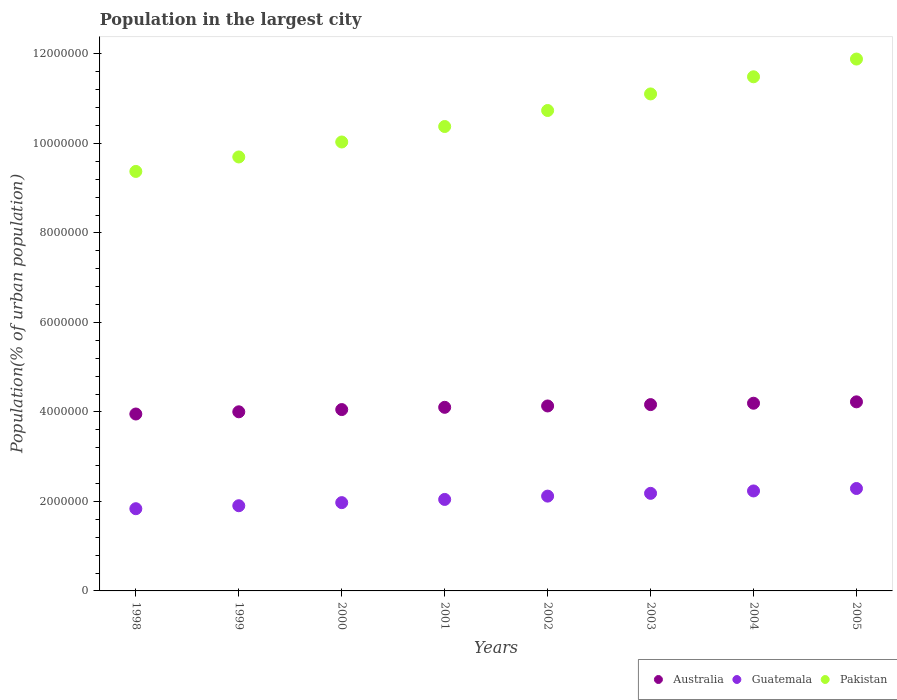Is the number of dotlines equal to the number of legend labels?
Your answer should be compact. Yes. What is the population in the largest city in Pakistan in 2000?
Make the answer very short. 1.00e+07. Across all years, what is the maximum population in the largest city in Pakistan?
Provide a succinct answer. 1.19e+07. Across all years, what is the minimum population in the largest city in Pakistan?
Your answer should be compact. 9.37e+06. What is the total population in the largest city in Australia in the graph?
Offer a terse response. 3.28e+07. What is the difference between the population in the largest city in Pakistan in 2002 and that in 2004?
Ensure brevity in your answer.  -7.53e+05. What is the difference between the population in the largest city in Guatemala in 2005 and the population in the largest city in Australia in 2000?
Provide a succinct answer. -1.76e+06. What is the average population in the largest city in Pakistan per year?
Provide a succinct answer. 1.06e+07. In the year 2005, what is the difference between the population in the largest city in Pakistan and population in the largest city in Australia?
Make the answer very short. 7.66e+06. In how many years, is the population in the largest city in Australia greater than 5200000 %?
Offer a very short reply. 0. What is the ratio of the population in the largest city in Australia in 2000 to that in 2003?
Your answer should be compact. 0.97. Is the population in the largest city in Australia in 1998 less than that in 2004?
Offer a terse response. Yes. Is the difference between the population in the largest city in Pakistan in 1999 and 2000 greater than the difference between the population in the largest city in Australia in 1999 and 2000?
Ensure brevity in your answer.  No. What is the difference between the highest and the second highest population in the largest city in Pakistan?
Your answer should be very brief. 3.96e+05. What is the difference between the highest and the lowest population in the largest city in Australia?
Provide a short and direct response. 2.72e+05. In how many years, is the population in the largest city in Guatemala greater than the average population in the largest city in Guatemala taken over all years?
Your answer should be very brief. 4. Is the sum of the population in the largest city in Australia in 2001 and 2005 greater than the maximum population in the largest city in Guatemala across all years?
Your response must be concise. Yes. How many years are there in the graph?
Your answer should be compact. 8. Does the graph contain any zero values?
Ensure brevity in your answer.  No. Does the graph contain grids?
Make the answer very short. No. Where does the legend appear in the graph?
Offer a terse response. Bottom right. How are the legend labels stacked?
Your answer should be very brief. Horizontal. What is the title of the graph?
Your response must be concise. Population in the largest city. Does "Serbia" appear as one of the legend labels in the graph?
Your answer should be compact. No. What is the label or title of the Y-axis?
Keep it short and to the point. Population(% of urban population). What is the Population(% of urban population) in Australia in 1998?
Provide a succinct answer. 3.95e+06. What is the Population(% of urban population) of Guatemala in 1998?
Your response must be concise. 1.84e+06. What is the Population(% of urban population) of Pakistan in 1998?
Give a very brief answer. 9.37e+06. What is the Population(% of urban population) of Australia in 1999?
Your response must be concise. 4.00e+06. What is the Population(% of urban population) of Guatemala in 1999?
Provide a short and direct response. 1.90e+06. What is the Population(% of urban population) in Pakistan in 1999?
Offer a terse response. 9.70e+06. What is the Population(% of urban population) in Australia in 2000?
Your answer should be compact. 4.05e+06. What is the Population(% of urban population) in Guatemala in 2000?
Provide a short and direct response. 1.97e+06. What is the Population(% of urban population) of Pakistan in 2000?
Make the answer very short. 1.00e+07. What is the Population(% of urban population) in Australia in 2001?
Provide a succinct answer. 4.10e+06. What is the Population(% of urban population) of Guatemala in 2001?
Offer a terse response. 2.04e+06. What is the Population(% of urban population) of Pakistan in 2001?
Make the answer very short. 1.04e+07. What is the Population(% of urban population) of Australia in 2002?
Provide a short and direct response. 4.13e+06. What is the Population(% of urban population) of Guatemala in 2002?
Your answer should be very brief. 2.12e+06. What is the Population(% of urban population) in Pakistan in 2002?
Your response must be concise. 1.07e+07. What is the Population(% of urban population) of Australia in 2003?
Keep it short and to the point. 4.16e+06. What is the Population(% of urban population) in Guatemala in 2003?
Ensure brevity in your answer.  2.18e+06. What is the Population(% of urban population) in Pakistan in 2003?
Make the answer very short. 1.11e+07. What is the Population(% of urban population) of Australia in 2004?
Your answer should be compact. 4.19e+06. What is the Population(% of urban population) of Guatemala in 2004?
Provide a succinct answer. 2.23e+06. What is the Population(% of urban population) in Pakistan in 2004?
Offer a very short reply. 1.15e+07. What is the Population(% of urban population) in Australia in 2005?
Your answer should be very brief. 4.23e+06. What is the Population(% of urban population) in Guatemala in 2005?
Keep it short and to the point. 2.29e+06. What is the Population(% of urban population) in Pakistan in 2005?
Offer a terse response. 1.19e+07. Across all years, what is the maximum Population(% of urban population) of Australia?
Keep it short and to the point. 4.23e+06. Across all years, what is the maximum Population(% of urban population) in Guatemala?
Give a very brief answer. 2.29e+06. Across all years, what is the maximum Population(% of urban population) of Pakistan?
Ensure brevity in your answer.  1.19e+07. Across all years, what is the minimum Population(% of urban population) of Australia?
Your response must be concise. 3.95e+06. Across all years, what is the minimum Population(% of urban population) in Guatemala?
Your answer should be compact. 1.84e+06. Across all years, what is the minimum Population(% of urban population) in Pakistan?
Offer a very short reply. 9.37e+06. What is the total Population(% of urban population) of Australia in the graph?
Your response must be concise. 3.28e+07. What is the total Population(% of urban population) in Guatemala in the graph?
Ensure brevity in your answer.  1.66e+07. What is the total Population(% of urban population) in Pakistan in the graph?
Your response must be concise. 8.47e+07. What is the difference between the Population(% of urban population) of Australia in 1998 and that in 1999?
Your answer should be very brief. -4.92e+04. What is the difference between the Population(% of urban population) in Guatemala in 1998 and that in 1999?
Provide a succinct answer. -6.66e+04. What is the difference between the Population(% of urban population) of Pakistan in 1998 and that in 1999?
Provide a succinct answer. -3.23e+05. What is the difference between the Population(% of urban population) in Australia in 1998 and that in 2000?
Give a very brief answer. -9.91e+04. What is the difference between the Population(% of urban population) in Guatemala in 1998 and that in 2000?
Provide a short and direct response. -1.36e+05. What is the difference between the Population(% of urban population) of Pakistan in 1998 and that in 2000?
Keep it short and to the point. -6.58e+05. What is the difference between the Population(% of urban population) in Australia in 1998 and that in 2001?
Provide a succinct answer. -1.49e+05. What is the difference between the Population(% of urban population) in Guatemala in 1998 and that in 2001?
Provide a short and direct response. -2.07e+05. What is the difference between the Population(% of urban population) in Pakistan in 1998 and that in 2001?
Your answer should be very brief. -1.00e+06. What is the difference between the Population(% of urban population) in Australia in 1998 and that in 2002?
Keep it short and to the point. -1.80e+05. What is the difference between the Population(% of urban population) in Guatemala in 1998 and that in 2002?
Offer a terse response. -2.81e+05. What is the difference between the Population(% of urban population) of Pakistan in 1998 and that in 2002?
Keep it short and to the point. -1.36e+06. What is the difference between the Population(% of urban population) of Australia in 1998 and that in 2003?
Provide a short and direct response. -2.10e+05. What is the difference between the Population(% of urban population) in Guatemala in 1998 and that in 2003?
Your answer should be compact. -3.43e+05. What is the difference between the Population(% of urban population) in Pakistan in 1998 and that in 2003?
Keep it short and to the point. -1.73e+06. What is the difference between the Population(% of urban population) in Australia in 1998 and that in 2004?
Provide a short and direct response. -2.41e+05. What is the difference between the Population(% of urban population) of Guatemala in 1998 and that in 2004?
Ensure brevity in your answer.  -3.97e+05. What is the difference between the Population(% of urban population) in Pakistan in 1998 and that in 2004?
Make the answer very short. -2.11e+06. What is the difference between the Population(% of urban population) of Australia in 1998 and that in 2005?
Offer a very short reply. -2.72e+05. What is the difference between the Population(% of urban population) of Guatemala in 1998 and that in 2005?
Provide a succinct answer. -4.52e+05. What is the difference between the Population(% of urban population) in Pakistan in 1998 and that in 2005?
Offer a terse response. -2.51e+06. What is the difference between the Population(% of urban population) of Australia in 1999 and that in 2000?
Your answer should be compact. -4.99e+04. What is the difference between the Population(% of urban population) in Guatemala in 1999 and that in 2000?
Keep it short and to the point. -6.91e+04. What is the difference between the Population(% of urban population) of Pakistan in 1999 and that in 2000?
Your response must be concise. -3.34e+05. What is the difference between the Population(% of urban population) in Australia in 1999 and that in 2001?
Offer a terse response. -1.00e+05. What is the difference between the Population(% of urban population) of Guatemala in 1999 and that in 2001?
Offer a very short reply. -1.41e+05. What is the difference between the Population(% of urban population) of Pakistan in 1999 and that in 2001?
Your response must be concise. -6.80e+05. What is the difference between the Population(% of urban population) in Australia in 1999 and that in 2002?
Offer a terse response. -1.30e+05. What is the difference between the Population(% of urban population) in Guatemala in 1999 and that in 2002?
Ensure brevity in your answer.  -2.15e+05. What is the difference between the Population(% of urban population) in Pakistan in 1999 and that in 2002?
Provide a succinct answer. -1.04e+06. What is the difference between the Population(% of urban population) in Australia in 1999 and that in 2003?
Your answer should be compact. -1.61e+05. What is the difference between the Population(% of urban population) of Guatemala in 1999 and that in 2003?
Offer a very short reply. -2.77e+05. What is the difference between the Population(% of urban population) of Pakistan in 1999 and that in 2003?
Keep it short and to the point. -1.41e+06. What is the difference between the Population(% of urban population) of Australia in 1999 and that in 2004?
Keep it short and to the point. -1.92e+05. What is the difference between the Population(% of urban population) in Guatemala in 1999 and that in 2004?
Make the answer very short. -3.30e+05. What is the difference between the Population(% of urban population) in Pakistan in 1999 and that in 2004?
Offer a terse response. -1.79e+06. What is the difference between the Population(% of urban population) of Australia in 1999 and that in 2005?
Offer a very short reply. -2.23e+05. What is the difference between the Population(% of urban population) in Guatemala in 1999 and that in 2005?
Provide a short and direct response. -3.85e+05. What is the difference between the Population(% of urban population) in Pakistan in 1999 and that in 2005?
Keep it short and to the point. -2.19e+06. What is the difference between the Population(% of urban population) of Australia in 2000 and that in 2001?
Keep it short and to the point. -5.02e+04. What is the difference between the Population(% of urban population) of Guatemala in 2000 and that in 2001?
Your response must be concise. -7.15e+04. What is the difference between the Population(% of urban population) in Pakistan in 2000 and that in 2001?
Provide a succinct answer. -3.46e+05. What is the difference between the Population(% of urban population) in Australia in 2000 and that in 2002?
Provide a succinct answer. -8.05e+04. What is the difference between the Population(% of urban population) of Guatemala in 2000 and that in 2002?
Provide a succinct answer. -1.46e+05. What is the difference between the Population(% of urban population) in Pakistan in 2000 and that in 2002?
Keep it short and to the point. -7.04e+05. What is the difference between the Population(% of urban population) in Australia in 2000 and that in 2003?
Your response must be concise. -1.11e+05. What is the difference between the Population(% of urban population) in Guatemala in 2000 and that in 2003?
Your answer should be very brief. -2.07e+05. What is the difference between the Population(% of urban population) of Pakistan in 2000 and that in 2003?
Keep it short and to the point. -1.07e+06. What is the difference between the Population(% of urban population) of Australia in 2000 and that in 2004?
Ensure brevity in your answer.  -1.42e+05. What is the difference between the Population(% of urban population) in Guatemala in 2000 and that in 2004?
Your answer should be very brief. -2.61e+05. What is the difference between the Population(% of urban population) of Pakistan in 2000 and that in 2004?
Your response must be concise. -1.46e+06. What is the difference between the Population(% of urban population) of Australia in 2000 and that in 2005?
Your answer should be compact. -1.73e+05. What is the difference between the Population(% of urban population) of Guatemala in 2000 and that in 2005?
Offer a terse response. -3.16e+05. What is the difference between the Population(% of urban population) of Pakistan in 2000 and that in 2005?
Ensure brevity in your answer.  -1.85e+06. What is the difference between the Population(% of urban population) in Australia in 2001 and that in 2002?
Make the answer very short. -3.03e+04. What is the difference between the Population(% of urban population) in Guatemala in 2001 and that in 2002?
Your response must be concise. -7.41e+04. What is the difference between the Population(% of urban population) of Pakistan in 2001 and that in 2002?
Make the answer very short. -3.58e+05. What is the difference between the Population(% of urban population) of Australia in 2001 and that in 2003?
Provide a short and direct response. -6.08e+04. What is the difference between the Population(% of urban population) of Guatemala in 2001 and that in 2003?
Give a very brief answer. -1.36e+05. What is the difference between the Population(% of urban population) in Pakistan in 2001 and that in 2003?
Offer a very short reply. -7.28e+05. What is the difference between the Population(% of urban population) in Australia in 2001 and that in 2004?
Your response must be concise. -9.15e+04. What is the difference between the Population(% of urban population) in Guatemala in 2001 and that in 2004?
Your answer should be very brief. -1.90e+05. What is the difference between the Population(% of urban population) of Pakistan in 2001 and that in 2004?
Provide a short and direct response. -1.11e+06. What is the difference between the Population(% of urban population) of Australia in 2001 and that in 2005?
Provide a succinct answer. -1.22e+05. What is the difference between the Population(% of urban population) in Guatemala in 2001 and that in 2005?
Offer a terse response. -2.44e+05. What is the difference between the Population(% of urban population) in Pakistan in 2001 and that in 2005?
Your response must be concise. -1.51e+06. What is the difference between the Population(% of urban population) in Australia in 2002 and that in 2003?
Provide a short and direct response. -3.05e+04. What is the difference between the Population(% of urban population) of Guatemala in 2002 and that in 2003?
Your response must be concise. -6.19e+04. What is the difference between the Population(% of urban population) of Pakistan in 2002 and that in 2003?
Offer a terse response. -3.70e+05. What is the difference between the Population(% of urban population) of Australia in 2002 and that in 2004?
Your response must be concise. -6.12e+04. What is the difference between the Population(% of urban population) in Guatemala in 2002 and that in 2004?
Your response must be concise. -1.15e+05. What is the difference between the Population(% of urban population) in Pakistan in 2002 and that in 2004?
Give a very brief answer. -7.53e+05. What is the difference between the Population(% of urban population) of Australia in 2002 and that in 2005?
Your answer should be very brief. -9.21e+04. What is the difference between the Population(% of urban population) in Guatemala in 2002 and that in 2005?
Offer a terse response. -1.70e+05. What is the difference between the Population(% of urban population) of Pakistan in 2002 and that in 2005?
Keep it short and to the point. -1.15e+06. What is the difference between the Population(% of urban population) of Australia in 2003 and that in 2004?
Offer a very short reply. -3.08e+04. What is the difference between the Population(% of urban population) of Guatemala in 2003 and that in 2004?
Provide a succinct answer. -5.36e+04. What is the difference between the Population(% of urban population) in Pakistan in 2003 and that in 2004?
Offer a terse response. -3.83e+05. What is the difference between the Population(% of urban population) in Australia in 2003 and that in 2005?
Ensure brevity in your answer.  -6.17e+04. What is the difference between the Population(% of urban population) of Guatemala in 2003 and that in 2005?
Ensure brevity in your answer.  -1.08e+05. What is the difference between the Population(% of urban population) of Pakistan in 2003 and that in 2005?
Make the answer very short. -7.79e+05. What is the difference between the Population(% of urban population) of Australia in 2004 and that in 2005?
Ensure brevity in your answer.  -3.09e+04. What is the difference between the Population(% of urban population) in Guatemala in 2004 and that in 2005?
Your answer should be compact. -5.47e+04. What is the difference between the Population(% of urban population) in Pakistan in 2004 and that in 2005?
Ensure brevity in your answer.  -3.96e+05. What is the difference between the Population(% of urban population) in Australia in 1998 and the Population(% of urban population) in Guatemala in 1999?
Provide a short and direct response. 2.05e+06. What is the difference between the Population(% of urban population) in Australia in 1998 and the Population(% of urban population) in Pakistan in 1999?
Give a very brief answer. -5.74e+06. What is the difference between the Population(% of urban population) in Guatemala in 1998 and the Population(% of urban population) in Pakistan in 1999?
Provide a succinct answer. -7.86e+06. What is the difference between the Population(% of urban population) of Australia in 1998 and the Population(% of urban population) of Guatemala in 2000?
Your answer should be very brief. 1.98e+06. What is the difference between the Population(% of urban population) of Australia in 1998 and the Population(% of urban population) of Pakistan in 2000?
Your response must be concise. -6.08e+06. What is the difference between the Population(% of urban population) in Guatemala in 1998 and the Population(% of urban population) in Pakistan in 2000?
Your answer should be very brief. -8.19e+06. What is the difference between the Population(% of urban population) in Australia in 1998 and the Population(% of urban population) in Guatemala in 2001?
Provide a short and direct response. 1.91e+06. What is the difference between the Population(% of urban population) in Australia in 1998 and the Population(% of urban population) in Pakistan in 2001?
Make the answer very short. -6.42e+06. What is the difference between the Population(% of urban population) in Guatemala in 1998 and the Population(% of urban population) in Pakistan in 2001?
Keep it short and to the point. -8.54e+06. What is the difference between the Population(% of urban population) in Australia in 1998 and the Population(% of urban population) in Guatemala in 2002?
Provide a short and direct response. 1.83e+06. What is the difference between the Population(% of urban population) in Australia in 1998 and the Population(% of urban population) in Pakistan in 2002?
Keep it short and to the point. -6.78e+06. What is the difference between the Population(% of urban population) in Guatemala in 1998 and the Population(% of urban population) in Pakistan in 2002?
Your answer should be very brief. -8.90e+06. What is the difference between the Population(% of urban population) in Australia in 1998 and the Population(% of urban population) in Guatemala in 2003?
Your response must be concise. 1.77e+06. What is the difference between the Population(% of urban population) in Australia in 1998 and the Population(% of urban population) in Pakistan in 2003?
Your answer should be very brief. -7.15e+06. What is the difference between the Population(% of urban population) of Guatemala in 1998 and the Population(% of urban population) of Pakistan in 2003?
Provide a short and direct response. -9.27e+06. What is the difference between the Population(% of urban population) of Australia in 1998 and the Population(% of urban population) of Guatemala in 2004?
Make the answer very short. 1.72e+06. What is the difference between the Population(% of urban population) of Australia in 1998 and the Population(% of urban population) of Pakistan in 2004?
Offer a terse response. -7.54e+06. What is the difference between the Population(% of urban population) in Guatemala in 1998 and the Population(% of urban population) in Pakistan in 2004?
Your answer should be very brief. -9.65e+06. What is the difference between the Population(% of urban population) in Australia in 1998 and the Population(% of urban population) in Guatemala in 2005?
Give a very brief answer. 1.66e+06. What is the difference between the Population(% of urban population) in Australia in 1998 and the Population(% of urban population) in Pakistan in 2005?
Keep it short and to the point. -7.93e+06. What is the difference between the Population(% of urban population) of Guatemala in 1998 and the Population(% of urban population) of Pakistan in 2005?
Offer a terse response. -1.00e+07. What is the difference between the Population(% of urban population) in Australia in 1999 and the Population(% of urban population) in Guatemala in 2000?
Your answer should be compact. 2.03e+06. What is the difference between the Population(% of urban population) of Australia in 1999 and the Population(% of urban population) of Pakistan in 2000?
Give a very brief answer. -6.03e+06. What is the difference between the Population(% of urban population) of Guatemala in 1999 and the Population(% of urban population) of Pakistan in 2000?
Make the answer very short. -8.13e+06. What is the difference between the Population(% of urban population) in Australia in 1999 and the Population(% of urban population) in Guatemala in 2001?
Make the answer very short. 1.96e+06. What is the difference between the Population(% of urban population) of Australia in 1999 and the Population(% of urban population) of Pakistan in 2001?
Offer a very short reply. -6.38e+06. What is the difference between the Population(% of urban population) in Guatemala in 1999 and the Population(% of urban population) in Pakistan in 2001?
Keep it short and to the point. -8.47e+06. What is the difference between the Population(% of urban population) in Australia in 1999 and the Population(% of urban population) in Guatemala in 2002?
Your response must be concise. 1.88e+06. What is the difference between the Population(% of urban population) in Australia in 1999 and the Population(% of urban population) in Pakistan in 2002?
Give a very brief answer. -6.73e+06. What is the difference between the Population(% of urban population) of Guatemala in 1999 and the Population(% of urban population) of Pakistan in 2002?
Your response must be concise. -8.83e+06. What is the difference between the Population(% of urban population) of Australia in 1999 and the Population(% of urban population) of Guatemala in 2003?
Your response must be concise. 1.82e+06. What is the difference between the Population(% of urban population) in Australia in 1999 and the Population(% of urban population) in Pakistan in 2003?
Ensure brevity in your answer.  -7.10e+06. What is the difference between the Population(% of urban population) of Guatemala in 1999 and the Population(% of urban population) of Pakistan in 2003?
Your answer should be compact. -9.20e+06. What is the difference between the Population(% of urban population) in Australia in 1999 and the Population(% of urban population) in Guatemala in 2004?
Provide a short and direct response. 1.77e+06. What is the difference between the Population(% of urban population) in Australia in 1999 and the Population(% of urban population) in Pakistan in 2004?
Offer a terse response. -7.49e+06. What is the difference between the Population(% of urban population) of Guatemala in 1999 and the Population(% of urban population) of Pakistan in 2004?
Provide a short and direct response. -9.59e+06. What is the difference between the Population(% of urban population) in Australia in 1999 and the Population(% of urban population) in Guatemala in 2005?
Make the answer very short. 1.71e+06. What is the difference between the Population(% of urban population) in Australia in 1999 and the Population(% of urban population) in Pakistan in 2005?
Provide a short and direct response. -7.88e+06. What is the difference between the Population(% of urban population) of Guatemala in 1999 and the Population(% of urban population) of Pakistan in 2005?
Make the answer very short. -9.98e+06. What is the difference between the Population(% of urban population) of Australia in 2000 and the Population(% of urban population) of Guatemala in 2001?
Make the answer very short. 2.01e+06. What is the difference between the Population(% of urban population) of Australia in 2000 and the Population(% of urban population) of Pakistan in 2001?
Offer a terse response. -6.33e+06. What is the difference between the Population(% of urban population) of Guatemala in 2000 and the Population(% of urban population) of Pakistan in 2001?
Provide a succinct answer. -8.40e+06. What is the difference between the Population(% of urban population) in Australia in 2000 and the Population(% of urban population) in Guatemala in 2002?
Ensure brevity in your answer.  1.93e+06. What is the difference between the Population(% of urban population) in Australia in 2000 and the Population(% of urban population) in Pakistan in 2002?
Keep it short and to the point. -6.68e+06. What is the difference between the Population(% of urban population) in Guatemala in 2000 and the Population(% of urban population) in Pakistan in 2002?
Your answer should be compact. -8.76e+06. What is the difference between the Population(% of urban population) in Australia in 2000 and the Population(% of urban population) in Guatemala in 2003?
Make the answer very short. 1.87e+06. What is the difference between the Population(% of urban population) in Australia in 2000 and the Population(% of urban population) in Pakistan in 2003?
Your response must be concise. -7.05e+06. What is the difference between the Population(% of urban population) of Guatemala in 2000 and the Population(% of urban population) of Pakistan in 2003?
Offer a terse response. -9.13e+06. What is the difference between the Population(% of urban population) in Australia in 2000 and the Population(% of urban population) in Guatemala in 2004?
Your response must be concise. 1.82e+06. What is the difference between the Population(% of urban population) in Australia in 2000 and the Population(% of urban population) in Pakistan in 2004?
Keep it short and to the point. -7.44e+06. What is the difference between the Population(% of urban population) in Guatemala in 2000 and the Population(% of urban population) in Pakistan in 2004?
Provide a short and direct response. -9.52e+06. What is the difference between the Population(% of urban population) in Australia in 2000 and the Population(% of urban population) in Guatemala in 2005?
Make the answer very short. 1.76e+06. What is the difference between the Population(% of urban population) in Australia in 2000 and the Population(% of urban population) in Pakistan in 2005?
Ensure brevity in your answer.  -7.83e+06. What is the difference between the Population(% of urban population) in Guatemala in 2000 and the Population(% of urban population) in Pakistan in 2005?
Provide a succinct answer. -9.91e+06. What is the difference between the Population(% of urban population) of Australia in 2001 and the Population(% of urban population) of Guatemala in 2002?
Your response must be concise. 1.98e+06. What is the difference between the Population(% of urban population) of Australia in 2001 and the Population(% of urban population) of Pakistan in 2002?
Your response must be concise. -6.63e+06. What is the difference between the Population(% of urban population) in Guatemala in 2001 and the Population(% of urban population) in Pakistan in 2002?
Keep it short and to the point. -8.69e+06. What is the difference between the Population(% of urban population) in Australia in 2001 and the Population(% of urban population) in Guatemala in 2003?
Offer a very short reply. 1.92e+06. What is the difference between the Population(% of urban population) of Australia in 2001 and the Population(% of urban population) of Pakistan in 2003?
Ensure brevity in your answer.  -7.00e+06. What is the difference between the Population(% of urban population) in Guatemala in 2001 and the Population(% of urban population) in Pakistan in 2003?
Make the answer very short. -9.06e+06. What is the difference between the Population(% of urban population) in Australia in 2001 and the Population(% of urban population) in Guatemala in 2004?
Offer a very short reply. 1.87e+06. What is the difference between the Population(% of urban population) in Australia in 2001 and the Population(% of urban population) in Pakistan in 2004?
Your response must be concise. -7.39e+06. What is the difference between the Population(% of urban population) of Guatemala in 2001 and the Population(% of urban population) of Pakistan in 2004?
Keep it short and to the point. -9.44e+06. What is the difference between the Population(% of urban population) of Australia in 2001 and the Population(% of urban population) of Guatemala in 2005?
Make the answer very short. 1.81e+06. What is the difference between the Population(% of urban population) of Australia in 2001 and the Population(% of urban population) of Pakistan in 2005?
Ensure brevity in your answer.  -7.78e+06. What is the difference between the Population(% of urban population) in Guatemala in 2001 and the Population(% of urban population) in Pakistan in 2005?
Make the answer very short. -9.84e+06. What is the difference between the Population(% of urban population) of Australia in 2002 and the Population(% of urban population) of Guatemala in 2003?
Give a very brief answer. 1.95e+06. What is the difference between the Population(% of urban population) of Australia in 2002 and the Population(% of urban population) of Pakistan in 2003?
Offer a terse response. -6.97e+06. What is the difference between the Population(% of urban population) in Guatemala in 2002 and the Population(% of urban population) in Pakistan in 2003?
Your response must be concise. -8.99e+06. What is the difference between the Population(% of urban population) in Australia in 2002 and the Population(% of urban population) in Guatemala in 2004?
Your response must be concise. 1.90e+06. What is the difference between the Population(% of urban population) in Australia in 2002 and the Population(% of urban population) in Pakistan in 2004?
Make the answer very short. -7.36e+06. What is the difference between the Population(% of urban population) of Guatemala in 2002 and the Population(% of urban population) of Pakistan in 2004?
Make the answer very short. -9.37e+06. What is the difference between the Population(% of urban population) of Australia in 2002 and the Population(% of urban population) of Guatemala in 2005?
Your answer should be compact. 1.84e+06. What is the difference between the Population(% of urban population) in Australia in 2002 and the Population(% of urban population) in Pakistan in 2005?
Offer a very short reply. -7.75e+06. What is the difference between the Population(% of urban population) in Guatemala in 2002 and the Population(% of urban population) in Pakistan in 2005?
Provide a succinct answer. -9.77e+06. What is the difference between the Population(% of urban population) in Australia in 2003 and the Population(% of urban population) in Guatemala in 2004?
Your response must be concise. 1.93e+06. What is the difference between the Population(% of urban population) of Australia in 2003 and the Population(% of urban population) of Pakistan in 2004?
Ensure brevity in your answer.  -7.33e+06. What is the difference between the Population(% of urban population) in Guatemala in 2003 and the Population(% of urban population) in Pakistan in 2004?
Make the answer very short. -9.31e+06. What is the difference between the Population(% of urban population) in Australia in 2003 and the Population(% of urban population) in Guatemala in 2005?
Give a very brief answer. 1.87e+06. What is the difference between the Population(% of urban population) in Australia in 2003 and the Population(% of urban population) in Pakistan in 2005?
Your answer should be compact. -7.72e+06. What is the difference between the Population(% of urban population) in Guatemala in 2003 and the Population(% of urban population) in Pakistan in 2005?
Your response must be concise. -9.70e+06. What is the difference between the Population(% of urban population) of Australia in 2004 and the Population(% of urban population) of Guatemala in 2005?
Ensure brevity in your answer.  1.91e+06. What is the difference between the Population(% of urban population) of Australia in 2004 and the Population(% of urban population) of Pakistan in 2005?
Give a very brief answer. -7.69e+06. What is the difference between the Population(% of urban population) of Guatemala in 2004 and the Population(% of urban population) of Pakistan in 2005?
Your answer should be compact. -9.65e+06. What is the average Population(% of urban population) of Australia per year?
Your answer should be very brief. 4.10e+06. What is the average Population(% of urban population) in Guatemala per year?
Ensure brevity in your answer.  2.07e+06. What is the average Population(% of urban population) of Pakistan per year?
Your response must be concise. 1.06e+07. In the year 1998, what is the difference between the Population(% of urban population) in Australia and Population(% of urban population) in Guatemala?
Provide a short and direct response. 2.12e+06. In the year 1998, what is the difference between the Population(% of urban population) in Australia and Population(% of urban population) in Pakistan?
Make the answer very short. -5.42e+06. In the year 1998, what is the difference between the Population(% of urban population) of Guatemala and Population(% of urban population) of Pakistan?
Keep it short and to the point. -7.54e+06. In the year 1999, what is the difference between the Population(% of urban population) in Australia and Population(% of urban population) in Guatemala?
Offer a terse response. 2.10e+06. In the year 1999, what is the difference between the Population(% of urban population) of Australia and Population(% of urban population) of Pakistan?
Your answer should be compact. -5.69e+06. In the year 1999, what is the difference between the Population(% of urban population) of Guatemala and Population(% of urban population) of Pakistan?
Make the answer very short. -7.79e+06. In the year 2000, what is the difference between the Population(% of urban population) of Australia and Population(% of urban population) of Guatemala?
Provide a short and direct response. 2.08e+06. In the year 2000, what is the difference between the Population(% of urban population) in Australia and Population(% of urban population) in Pakistan?
Your answer should be very brief. -5.98e+06. In the year 2000, what is the difference between the Population(% of urban population) in Guatemala and Population(% of urban population) in Pakistan?
Offer a very short reply. -8.06e+06. In the year 2001, what is the difference between the Population(% of urban population) in Australia and Population(% of urban population) in Guatemala?
Offer a very short reply. 2.06e+06. In the year 2001, what is the difference between the Population(% of urban population) in Australia and Population(% of urban population) in Pakistan?
Offer a very short reply. -6.27e+06. In the year 2001, what is the difference between the Population(% of urban population) of Guatemala and Population(% of urban population) of Pakistan?
Give a very brief answer. -8.33e+06. In the year 2002, what is the difference between the Population(% of urban population) of Australia and Population(% of urban population) of Guatemala?
Give a very brief answer. 2.01e+06. In the year 2002, what is the difference between the Population(% of urban population) in Australia and Population(% of urban population) in Pakistan?
Ensure brevity in your answer.  -6.60e+06. In the year 2002, what is the difference between the Population(% of urban population) of Guatemala and Population(% of urban population) of Pakistan?
Offer a very short reply. -8.62e+06. In the year 2003, what is the difference between the Population(% of urban population) of Australia and Population(% of urban population) of Guatemala?
Make the answer very short. 1.98e+06. In the year 2003, what is the difference between the Population(% of urban population) in Australia and Population(% of urban population) in Pakistan?
Ensure brevity in your answer.  -6.94e+06. In the year 2003, what is the difference between the Population(% of urban population) in Guatemala and Population(% of urban population) in Pakistan?
Provide a short and direct response. -8.93e+06. In the year 2004, what is the difference between the Population(% of urban population) in Australia and Population(% of urban population) in Guatemala?
Your answer should be compact. 1.96e+06. In the year 2004, what is the difference between the Population(% of urban population) in Australia and Population(% of urban population) in Pakistan?
Ensure brevity in your answer.  -7.29e+06. In the year 2004, what is the difference between the Population(% of urban population) in Guatemala and Population(% of urban population) in Pakistan?
Provide a succinct answer. -9.25e+06. In the year 2005, what is the difference between the Population(% of urban population) of Australia and Population(% of urban population) of Guatemala?
Make the answer very short. 1.94e+06. In the year 2005, what is the difference between the Population(% of urban population) in Australia and Population(% of urban population) in Pakistan?
Keep it short and to the point. -7.66e+06. In the year 2005, what is the difference between the Population(% of urban population) in Guatemala and Population(% of urban population) in Pakistan?
Provide a short and direct response. -9.60e+06. What is the ratio of the Population(% of urban population) in Pakistan in 1998 to that in 1999?
Your answer should be compact. 0.97. What is the ratio of the Population(% of urban population) in Australia in 1998 to that in 2000?
Your answer should be compact. 0.98. What is the ratio of the Population(% of urban population) in Guatemala in 1998 to that in 2000?
Your answer should be compact. 0.93. What is the ratio of the Population(% of urban population) of Pakistan in 1998 to that in 2000?
Give a very brief answer. 0.93. What is the ratio of the Population(% of urban population) in Australia in 1998 to that in 2001?
Offer a very short reply. 0.96. What is the ratio of the Population(% of urban population) of Guatemala in 1998 to that in 2001?
Give a very brief answer. 0.9. What is the ratio of the Population(% of urban population) in Pakistan in 1998 to that in 2001?
Offer a very short reply. 0.9. What is the ratio of the Population(% of urban population) in Australia in 1998 to that in 2002?
Your answer should be compact. 0.96. What is the ratio of the Population(% of urban population) of Guatemala in 1998 to that in 2002?
Ensure brevity in your answer.  0.87. What is the ratio of the Population(% of urban population) of Pakistan in 1998 to that in 2002?
Offer a terse response. 0.87. What is the ratio of the Population(% of urban population) of Australia in 1998 to that in 2003?
Provide a short and direct response. 0.95. What is the ratio of the Population(% of urban population) of Guatemala in 1998 to that in 2003?
Make the answer very short. 0.84. What is the ratio of the Population(% of urban population) of Pakistan in 1998 to that in 2003?
Your answer should be compact. 0.84. What is the ratio of the Population(% of urban population) in Australia in 1998 to that in 2004?
Give a very brief answer. 0.94. What is the ratio of the Population(% of urban population) in Guatemala in 1998 to that in 2004?
Make the answer very short. 0.82. What is the ratio of the Population(% of urban population) of Pakistan in 1998 to that in 2004?
Offer a terse response. 0.82. What is the ratio of the Population(% of urban population) of Australia in 1998 to that in 2005?
Ensure brevity in your answer.  0.94. What is the ratio of the Population(% of urban population) in Guatemala in 1998 to that in 2005?
Your answer should be very brief. 0.8. What is the ratio of the Population(% of urban population) of Pakistan in 1998 to that in 2005?
Provide a succinct answer. 0.79. What is the ratio of the Population(% of urban population) in Guatemala in 1999 to that in 2000?
Provide a succinct answer. 0.96. What is the ratio of the Population(% of urban population) of Pakistan in 1999 to that in 2000?
Offer a very short reply. 0.97. What is the ratio of the Population(% of urban population) of Australia in 1999 to that in 2001?
Give a very brief answer. 0.98. What is the ratio of the Population(% of urban population) in Guatemala in 1999 to that in 2001?
Offer a very short reply. 0.93. What is the ratio of the Population(% of urban population) in Pakistan in 1999 to that in 2001?
Give a very brief answer. 0.93. What is the ratio of the Population(% of urban population) of Australia in 1999 to that in 2002?
Make the answer very short. 0.97. What is the ratio of the Population(% of urban population) in Guatemala in 1999 to that in 2002?
Provide a short and direct response. 0.9. What is the ratio of the Population(% of urban population) in Pakistan in 1999 to that in 2002?
Keep it short and to the point. 0.9. What is the ratio of the Population(% of urban population) in Australia in 1999 to that in 2003?
Provide a succinct answer. 0.96. What is the ratio of the Population(% of urban population) of Guatemala in 1999 to that in 2003?
Your answer should be very brief. 0.87. What is the ratio of the Population(% of urban population) in Pakistan in 1999 to that in 2003?
Offer a very short reply. 0.87. What is the ratio of the Population(% of urban population) in Australia in 1999 to that in 2004?
Offer a terse response. 0.95. What is the ratio of the Population(% of urban population) in Guatemala in 1999 to that in 2004?
Make the answer very short. 0.85. What is the ratio of the Population(% of urban population) of Pakistan in 1999 to that in 2004?
Make the answer very short. 0.84. What is the ratio of the Population(% of urban population) in Australia in 1999 to that in 2005?
Your response must be concise. 0.95. What is the ratio of the Population(% of urban population) of Guatemala in 1999 to that in 2005?
Offer a terse response. 0.83. What is the ratio of the Population(% of urban population) in Pakistan in 1999 to that in 2005?
Provide a short and direct response. 0.82. What is the ratio of the Population(% of urban population) in Guatemala in 2000 to that in 2001?
Ensure brevity in your answer.  0.96. What is the ratio of the Population(% of urban population) in Pakistan in 2000 to that in 2001?
Your answer should be compact. 0.97. What is the ratio of the Population(% of urban population) in Australia in 2000 to that in 2002?
Your answer should be very brief. 0.98. What is the ratio of the Population(% of urban population) of Guatemala in 2000 to that in 2002?
Keep it short and to the point. 0.93. What is the ratio of the Population(% of urban population) of Pakistan in 2000 to that in 2002?
Give a very brief answer. 0.93. What is the ratio of the Population(% of urban population) of Australia in 2000 to that in 2003?
Provide a short and direct response. 0.97. What is the ratio of the Population(% of urban population) in Guatemala in 2000 to that in 2003?
Keep it short and to the point. 0.9. What is the ratio of the Population(% of urban population) of Pakistan in 2000 to that in 2003?
Ensure brevity in your answer.  0.9. What is the ratio of the Population(% of urban population) in Australia in 2000 to that in 2004?
Provide a short and direct response. 0.97. What is the ratio of the Population(% of urban population) in Guatemala in 2000 to that in 2004?
Ensure brevity in your answer.  0.88. What is the ratio of the Population(% of urban population) of Pakistan in 2000 to that in 2004?
Your answer should be very brief. 0.87. What is the ratio of the Population(% of urban population) in Australia in 2000 to that in 2005?
Give a very brief answer. 0.96. What is the ratio of the Population(% of urban population) of Guatemala in 2000 to that in 2005?
Your response must be concise. 0.86. What is the ratio of the Population(% of urban population) in Pakistan in 2000 to that in 2005?
Your answer should be compact. 0.84. What is the ratio of the Population(% of urban population) of Pakistan in 2001 to that in 2002?
Ensure brevity in your answer.  0.97. What is the ratio of the Population(% of urban population) of Australia in 2001 to that in 2003?
Ensure brevity in your answer.  0.99. What is the ratio of the Population(% of urban population) of Guatemala in 2001 to that in 2003?
Your answer should be compact. 0.94. What is the ratio of the Population(% of urban population) in Pakistan in 2001 to that in 2003?
Provide a succinct answer. 0.93. What is the ratio of the Population(% of urban population) in Australia in 2001 to that in 2004?
Your response must be concise. 0.98. What is the ratio of the Population(% of urban population) in Guatemala in 2001 to that in 2004?
Keep it short and to the point. 0.92. What is the ratio of the Population(% of urban population) in Pakistan in 2001 to that in 2004?
Offer a very short reply. 0.9. What is the ratio of the Population(% of urban population) of Australia in 2001 to that in 2005?
Your answer should be compact. 0.97. What is the ratio of the Population(% of urban population) in Guatemala in 2001 to that in 2005?
Make the answer very short. 0.89. What is the ratio of the Population(% of urban population) in Pakistan in 2001 to that in 2005?
Give a very brief answer. 0.87. What is the ratio of the Population(% of urban population) in Guatemala in 2002 to that in 2003?
Make the answer very short. 0.97. What is the ratio of the Population(% of urban population) in Pakistan in 2002 to that in 2003?
Ensure brevity in your answer.  0.97. What is the ratio of the Population(% of urban population) of Australia in 2002 to that in 2004?
Provide a succinct answer. 0.99. What is the ratio of the Population(% of urban population) of Guatemala in 2002 to that in 2004?
Make the answer very short. 0.95. What is the ratio of the Population(% of urban population) in Pakistan in 2002 to that in 2004?
Offer a terse response. 0.93. What is the ratio of the Population(% of urban population) of Australia in 2002 to that in 2005?
Your response must be concise. 0.98. What is the ratio of the Population(% of urban population) in Guatemala in 2002 to that in 2005?
Provide a short and direct response. 0.93. What is the ratio of the Population(% of urban population) of Pakistan in 2002 to that in 2005?
Provide a short and direct response. 0.9. What is the ratio of the Population(% of urban population) in Australia in 2003 to that in 2004?
Offer a terse response. 0.99. What is the ratio of the Population(% of urban population) of Guatemala in 2003 to that in 2004?
Provide a succinct answer. 0.98. What is the ratio of the Population(% of urban population) of Pakistan in 2003 to that in 2004?
Provide a succinct answer. 0.97. What is the ratio of the Population(% of urban population) of Australia in 2003 to that in 2005?
Your response must be concise. 0.99. What is the ratio of the Population(% of urban population) of Guatemala in 2003 to that in 2005?
Make the answer very short. 0.95. What is the ratio of the Population(% of urban population) in Pakistan in 2003 to that in 2005?
Give a very brief answer. 0.93. What is the ratio of the Population(% of urban population) of Guatemala in 2004 to that in 2005?
Keep it short and to the point. 0.98. What is the ratio of the Population(% of urban population) in Pakistan in 2004 to that in 2005?
Your response must be concise. 0.97. What is the difference between the highest and the second highest Population(% of urban population) in Australia?
Give a very brief answer. 3.09e+04. What is the difference between the highest and the second highest Population(% of urban population) of Guatemala?
Make the answer very short. 5.47e+04. What is the difference between the highest and the second highest Population(% of urban population) of Pakistan?
Offer a very short reply. 3.96e+05. What is the difference between the highest and the lowest Population(% of urban population) of Australia?
Ensure brevity in your answer.  2.72e+05. What is the difference between the highest and the lowest Population(% of urban population) in Guatemala?
Your answer should be very brief. 4.52e+05. What is the difference between the highest and the lowest Population(% of urban population) in Pakistan?
Your answer should be very brief. 2.51e+06. 